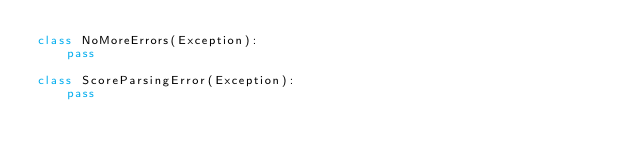Convert code to text. <code><loc_0><loc_0><loc_500><loc_500><_Python_>class NoMoreErrors(Exception):
    pass

class ScoreParsingError(Exception):
    pass

</code> 